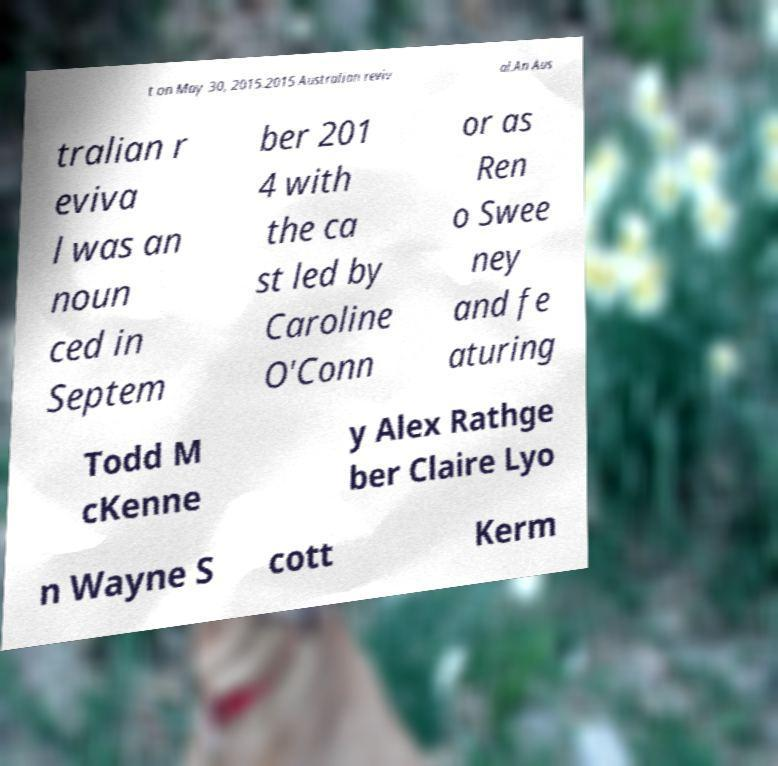Can you accurately transcribe the text from the provided image for me? t on May 30, 2015.2015 Australian reviv al.An Aus tralian r eviva l was an noun ced in Septem ber 201 4 with the ca st led by Caroline O'Conn or as Ren o Swee ney and fe aturing Todd M cKenne y Alex Rathge ber Claire Lyo n Wayne S cott Kerm 